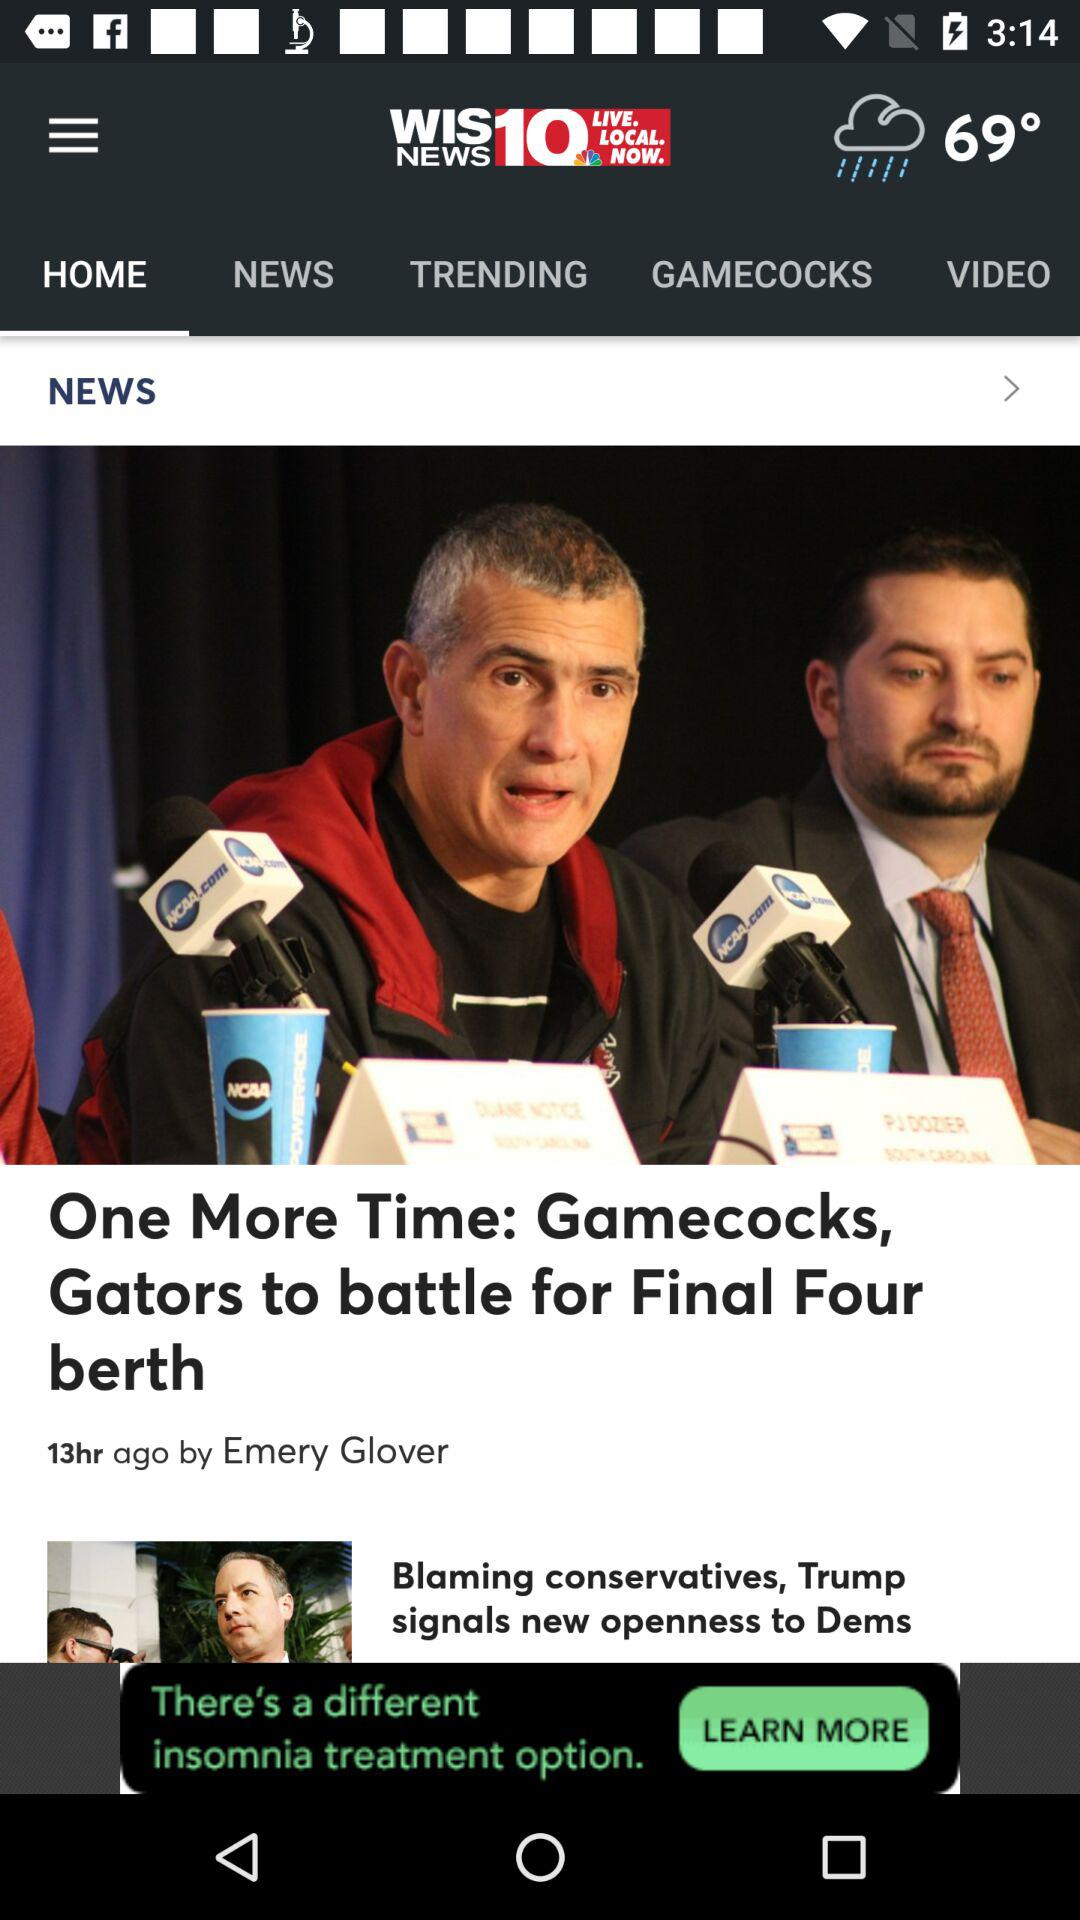How many hours ago was the news "One More Time: Gamecocks, Gators to battle for Final Four berth" published? The news "One More Time: Gamecocks, Gators to battle for Final Four berth" was published 13 hours ago. 